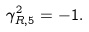<formula> <loc_0><loc_0><loc_500><loc_500>\gamma _ { R , 5 } ^ { 2 } = - 1 .</formula> 